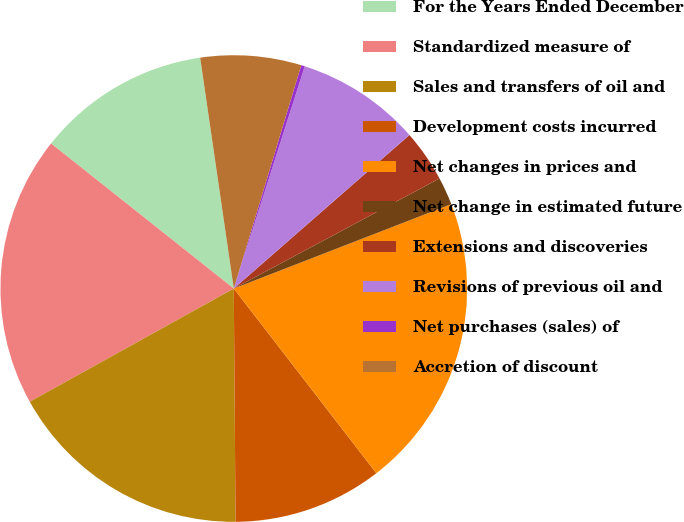Convert chart to OTSL. <chart><loc_0><loc_0><loc_500><loc_500><pie_chart><fcel>For the Years Ended December<fcel>Standardized measure of<fcel>Sales and transfers of oil and<fcel>Development costs incurred<fcel>Net changes in prices and<fcel>Net change in estimated future<fcel>Extensions and discoveries<fcel>Revisions of previous oil and<fcel>Net purchases (sales) of<fcel>Accretion of discount<nl><fcel>12.02%<fcel>18.74%<fcel>17.06%<fcel>10.34%<fcel>20.43%<fcel>1.93%<fcel>3.61%<fcel>8.65%<fcel>0.25%<fcel>6.97%<nl></chart> 